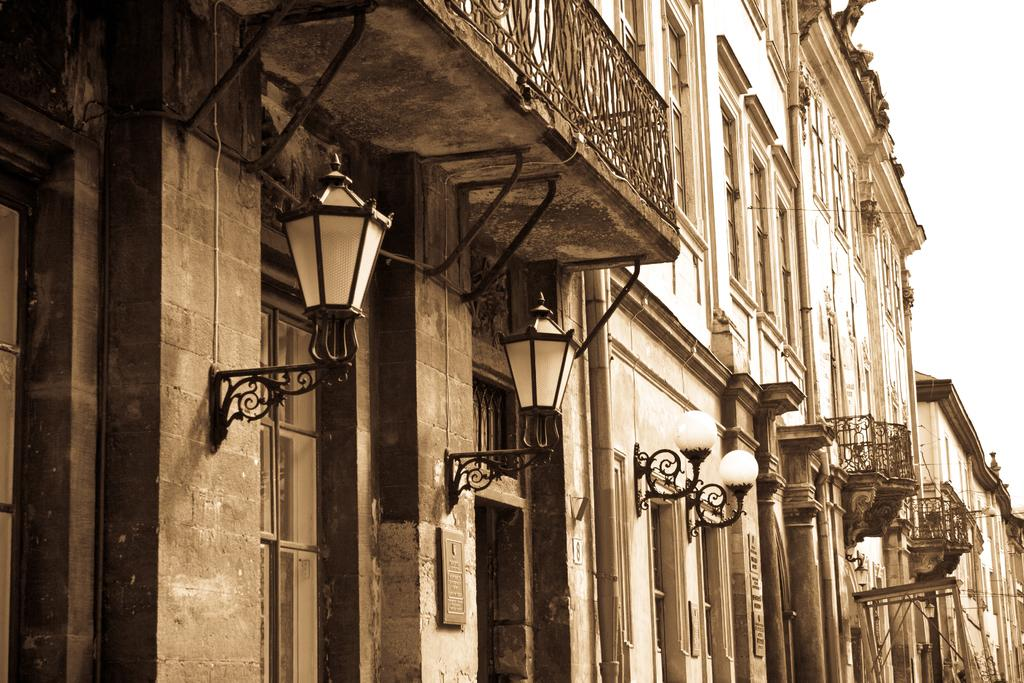What type of structure is present in the image? There is a building in the image. What features can be seen on the building? The building has windows and doors. Are there any additional elements attached to the building? Yes, lights are attached to the walls of the building. What can be seen on the right side of the image? The sky is visible on the right side of the image. What type of blood vessels can be seen in the image? There are no blood vessels present in the image; it features a building with windows, doors, and lights. How does the ink flow in the image? There is no ink present in the image; it features a building with windows, doors, and lights. 